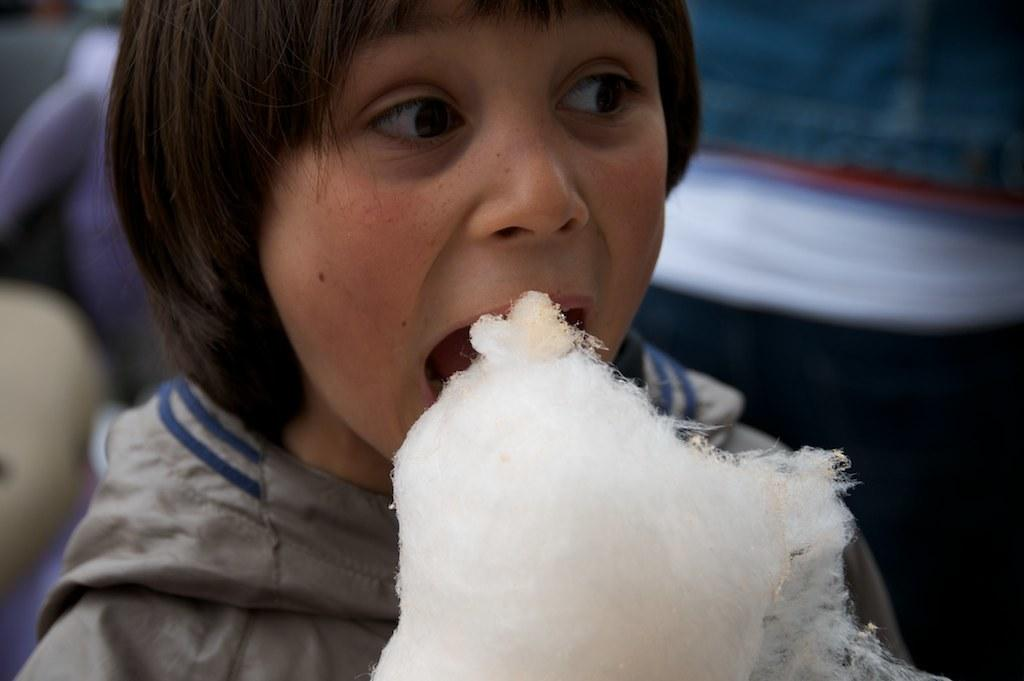Who is the main subject in the image? There is a girl in the image. What is the girl doing in the image? The girl is eating cotton candy. What can be seen in the background of the image? There are many people in the background of the image. What is the girl wearing in the image? The girl is wearing a gray jacket. What type of pets does the girl have in the image? There are no pets visible in the image. How does the girl use the wrench while eating cotton candy? There is no wrench present in the image, so it cannot be used by the girl. 